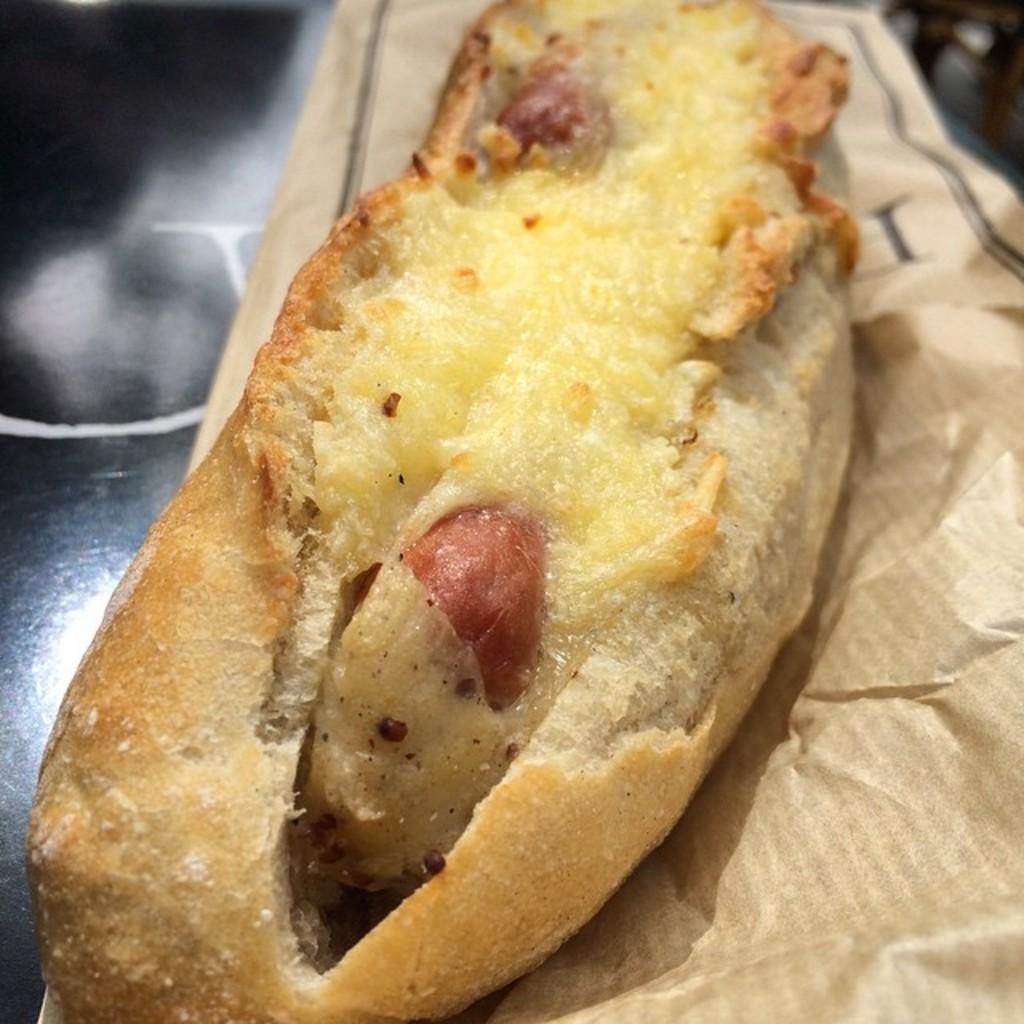Can you describe this image briefly? This image consists of food which is in the center and there is a paper which is brown in colour. 